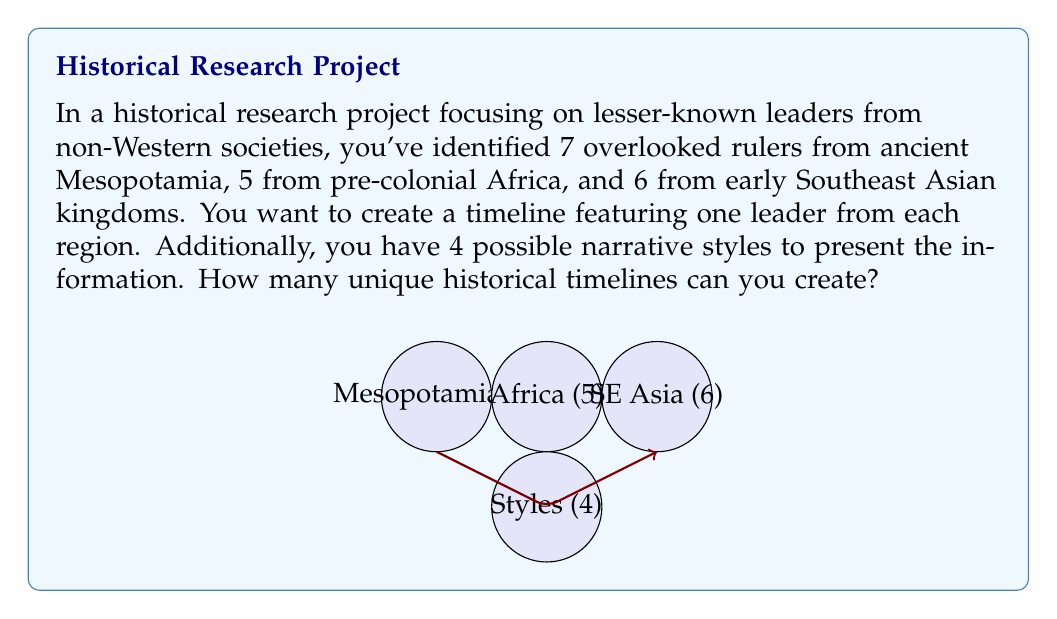Can you answer this question? Let's approach this step-by-step using the multiplication principle of combinatorics:

1) For each timeline, we need to choose:
   - One leader from Mesopotamia
   - One leader from Africa
   - One leader from Southeast Asia
   - One narrative style

2) The choices for each category are independent of each other. This means we can multiply the number of choices for each category to get the total number of possible combinations.

3) Let's count the choices for each category:
   - Mesopotamia: 7 choices
   - Africa: 5 choices
   - Southeast Asia: 6 choices
   - Narrative styles: 4 choices

4) Using the multiplication principle, we multiply these numbers:

   $$ 7 \times 5 \times 6 \times 4 $$

5) Let's calculate:
   $$ 7 \times 5 = 35 $$
   $$ 35 \times 6 = 210 $$
   $$ 210 \times 4 = 840 $$

Therefore, the total number of unique historical timelines that can be created is 840.
Answer: 840 unique timelines 